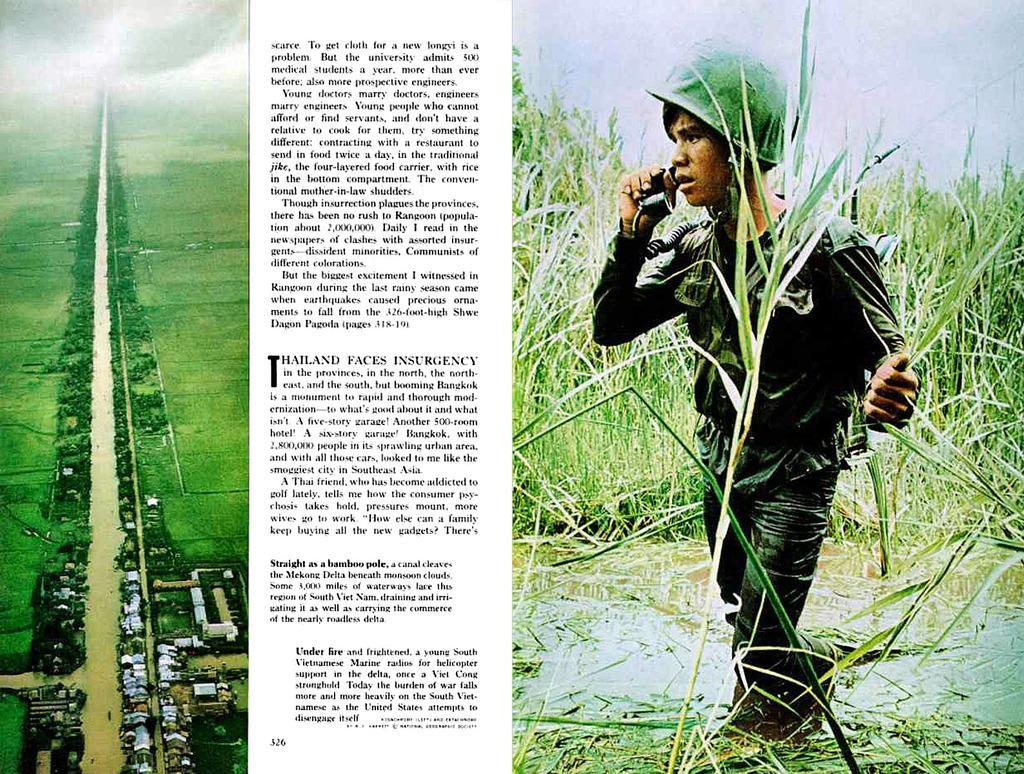In one or two sentences, can you explain what this image depicts? In this picture we can see a poster,on this poster we can see a person holding telephone and wore helmet and we can see grass and vehicles. 